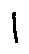<formula> <loc_0><loc_0><loc_500><loc_500>l</formula> 